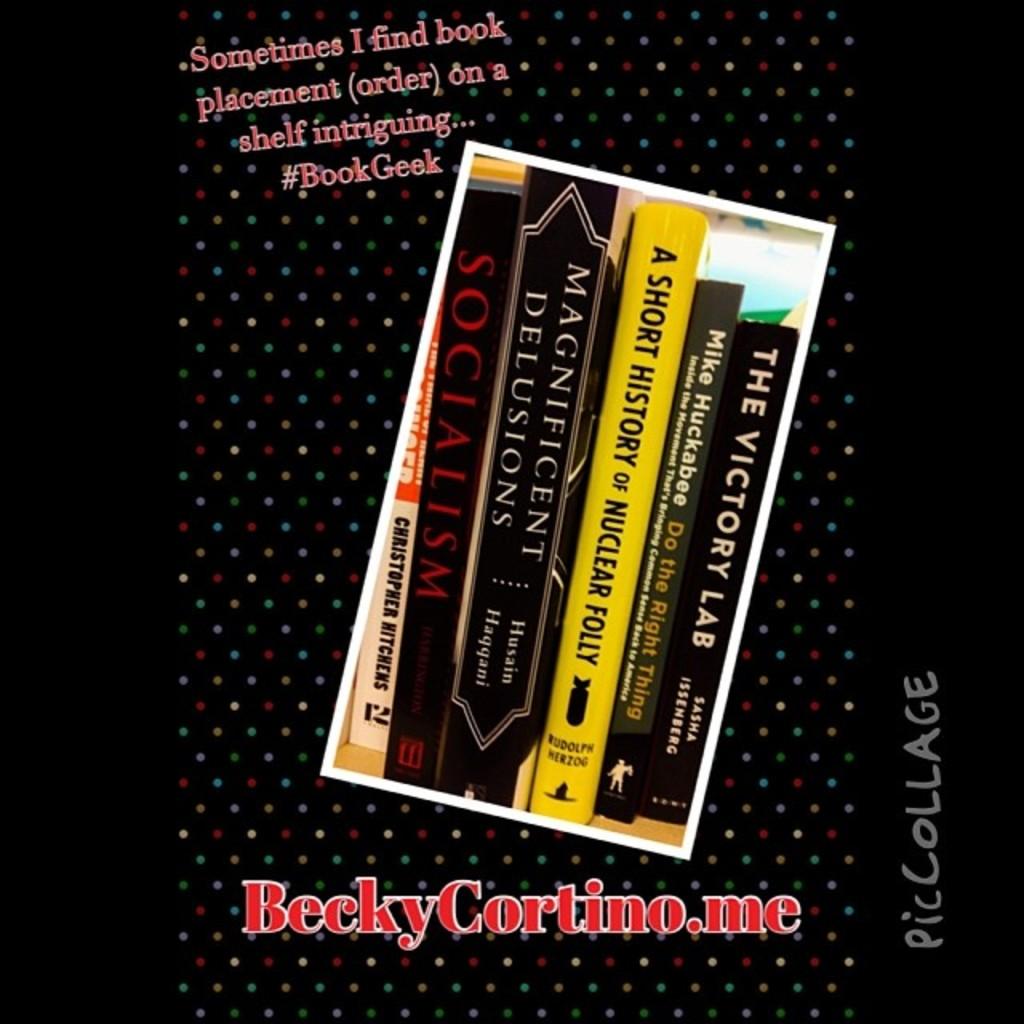What is the website address?
Your answer should be very brief. Beckycortino.me. 